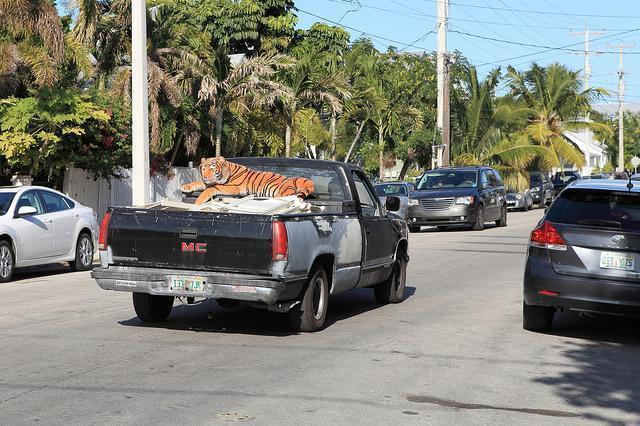How many cars are there?
Give a very brief answer. 3. 